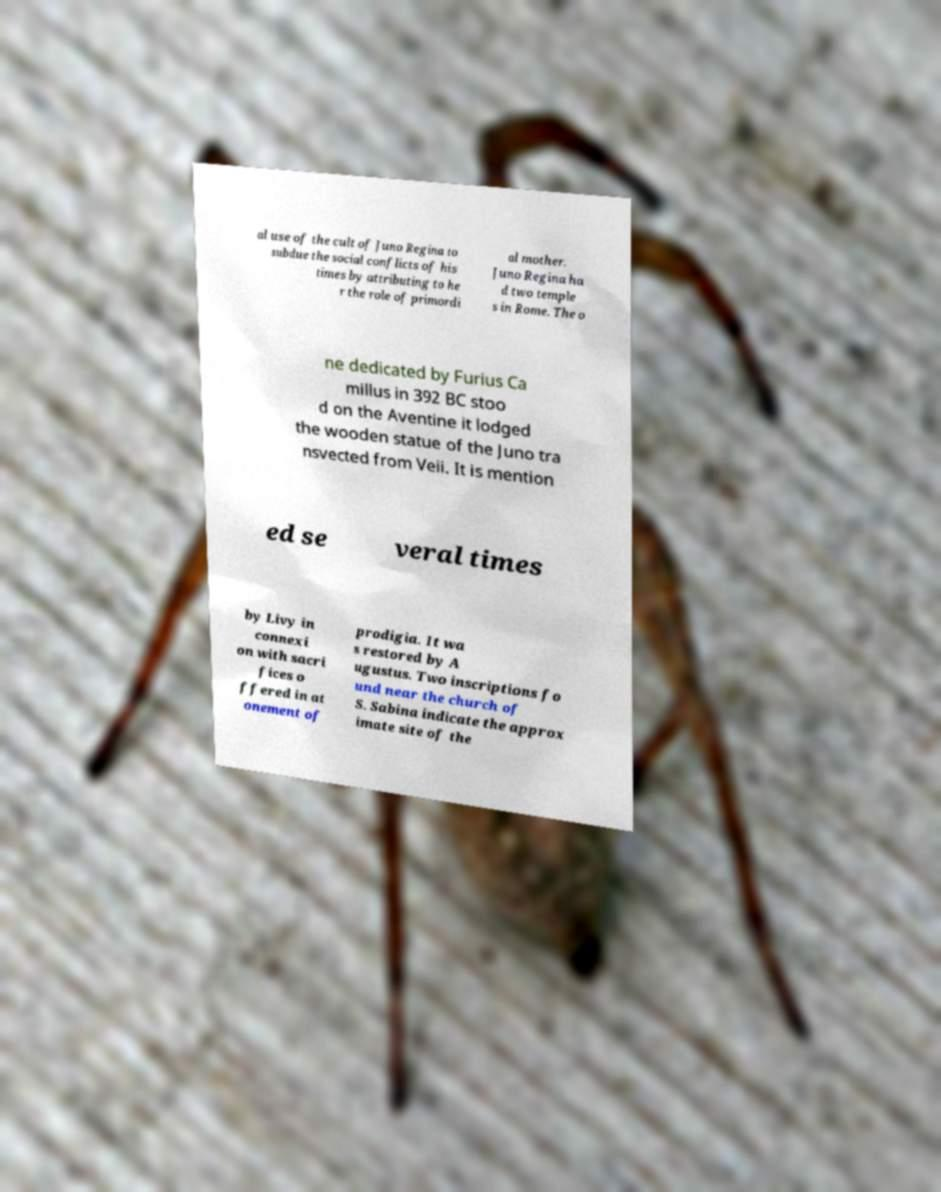What messages or text are displayed in this image? I need them in a readable, typed format. al use of the cult of Juno Regina to subdue the social conflicts of his times by attributing to he r the role of primordi al mother. Juno Regina ha d two temple s in Rome. The o ne dedicated by Furius Ca millus in 392 BC stoo d on the Aventine it lodged the wooden statue of the Juno tra nsvected from Veii. It is mention ed se veral times by Livy in connexi on with sacri fices o ffered in at onement of prodigia. It wa s restored by A ugustus. Two inscriptions fo und near the church of S. Sabina indicate the approx imate site of the 